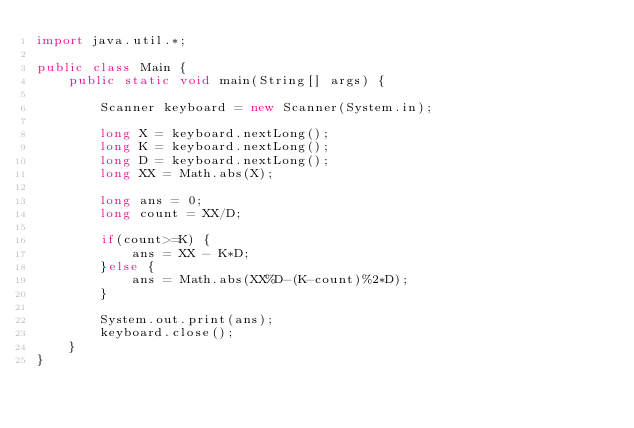Convert code to text. <code><loc_0><loc_0><loc_500><loc_500><_Java_>import java.util.*;

public class Main {
	public static void main(String[] args) {
		
		Scanner keyboard = new Scanner(System.in); 
		
		long X = keyboard.nextLong();
		long K = keyboard.nextLong();
		long D = keyboard.nextLong();
		long XX = Math.abs(X);
		
		long ans = 0;
		long count = XX/D;
		
		if(count>=K) {
			ans = XX - K*D;
		}else {
			ans = Math.abs(XX%D-(K-count)%2*D);
		}
		
		System.out.print(ans);
		keyboard.close();
	}
}</code> 